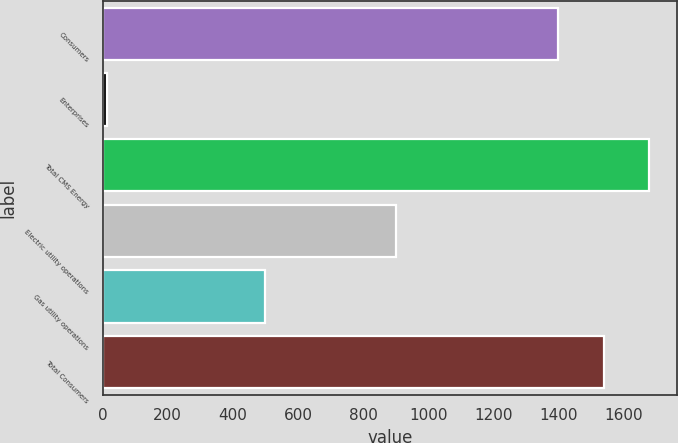<chart> <loc_0><loc_0><loc_500><loc_500><bar_chart><fcel>Consumers<fcel>Enterprises<fcel>Total CMS Energy<fcel>Electric utility operations<fcel>Gas utility operations<fcel>Total Consumers<nl><fcel>1400<fcel>13<fcel>1680<fcel>900<fcel>500<fcel>1540<nl></chart> 